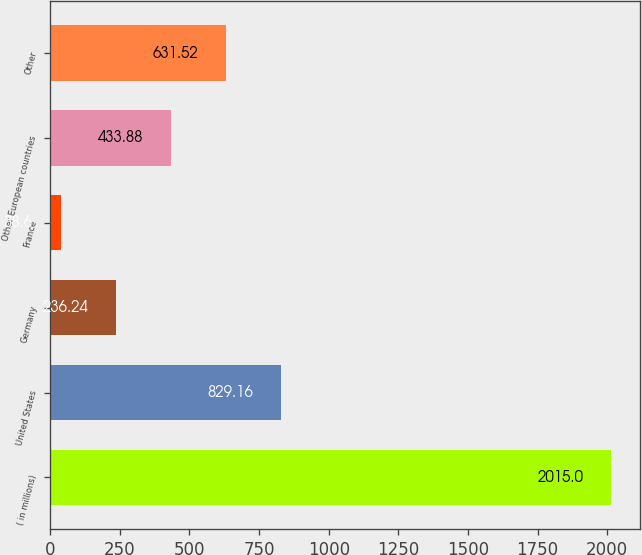<chart> <loc_0><loc_0><loc_500><loc_500><bar_chart><fcel>( in millions)<fcel>United States<fcel>Germany<fcel>France<fcel>Other European countries<fcel>Other<nl><fcel>2015<fcel>829.16<fcel>236.24<fcel>38.6<fcel>433.88<fcel>631.52<nl></chart> 